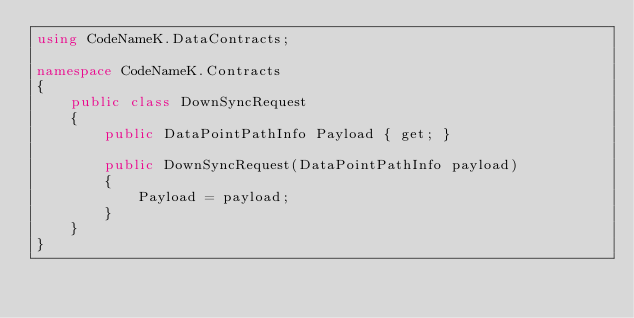Convert code to text. <code><loc_0><loc_0><loc_500><loc_500><_C#_>using CodeNameK.DataContracts;

namespace CodeNameK.Contracts
{
    public class DownSyncRequest
    {
        public DataPointPathInfo Payload { get; }

        public DownSyncRequest(DataPointPathInfo payload)
        {
            Payload = payload;
        }
    }
}</code> 